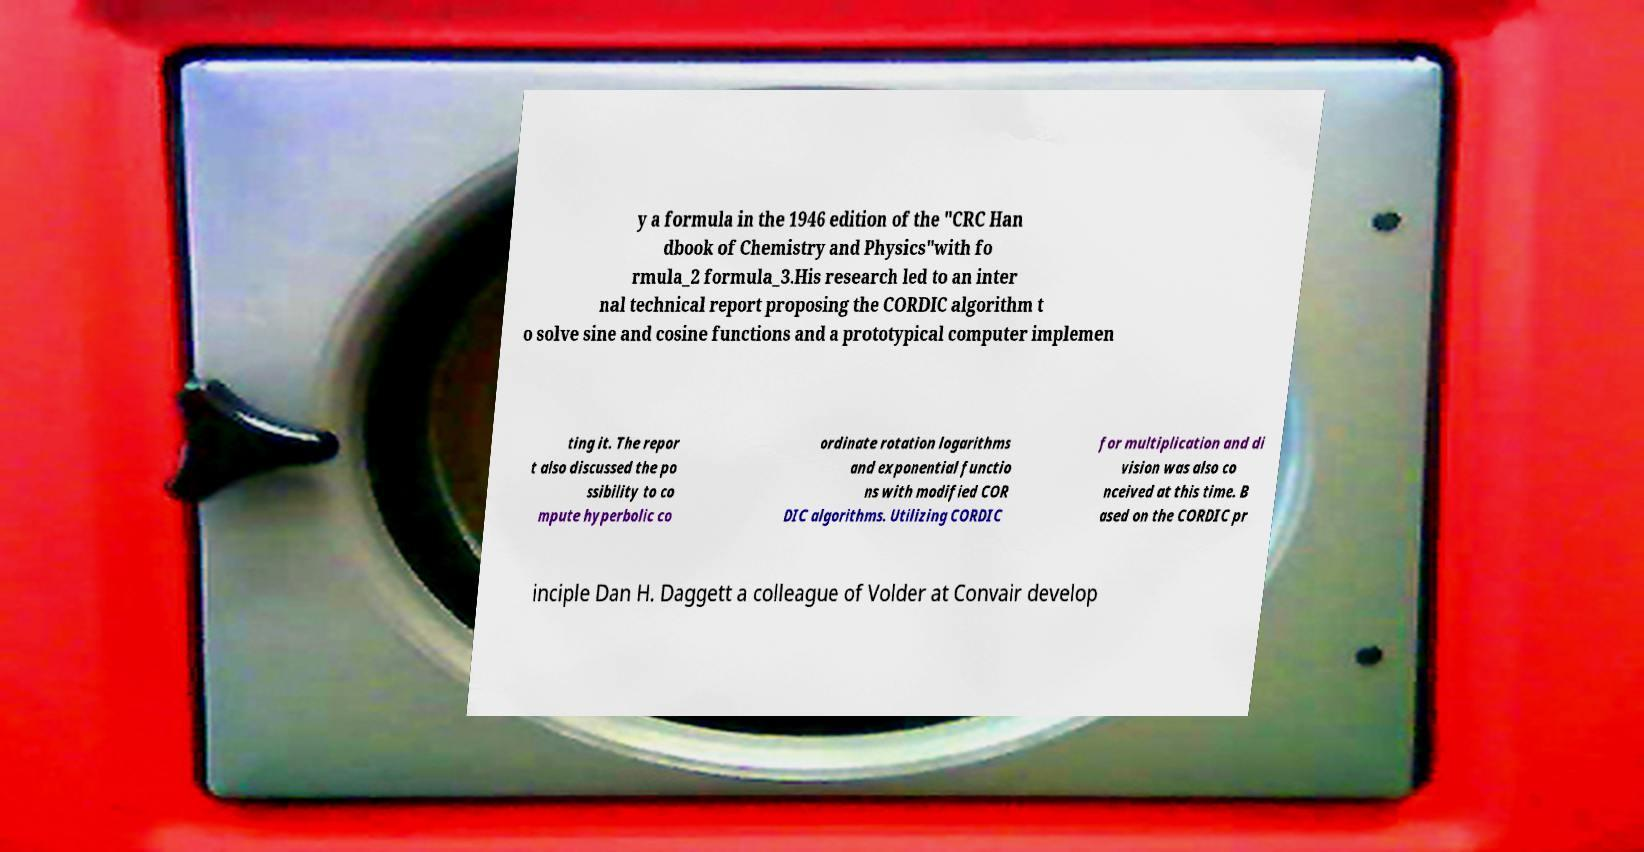There's text embedded in this image that I need extracted. Can you transcribe it verbatim? y a formula in the 1946 edition of the "CRC Han dbook of Chemistry and Physics"with fo rmula_2 formula_3.His research led to an inter nal technical report proposing the CORDIC algorithm t o solve sine and cosine functions and a prototypical computer implemen ting it. The repor t also discussed the po ssibility to co mpute hyperbolic co ordinate rotation logarithms and exponential functio ns with modified COR DIC algorithms. Utilizing CORDIC for multiplication and di vision was also co nceived at this time. B ased on the CORDIC pr inciple Dan H. Daggett a colleague of Volder at Convair develop 